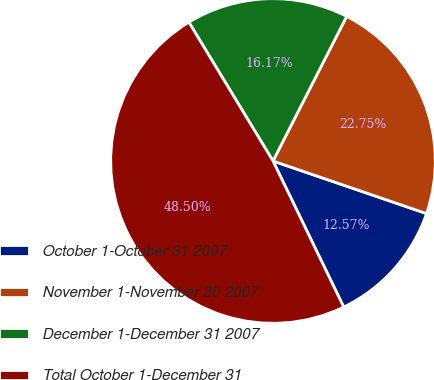Convert chart to OTSL. <chart><loc_0><loc_0><loc_500><loc_500><pie_chart><fcel>October 1-October 31 2007<fcel>November 1-November 30 2007<fcel>December 1-December 31 2007<fcel>Total October 1-December 31<nl><fcel>12.57%<fcel>22.75%<fcel>16.17%<fcel>48.5%<nl></chart> 